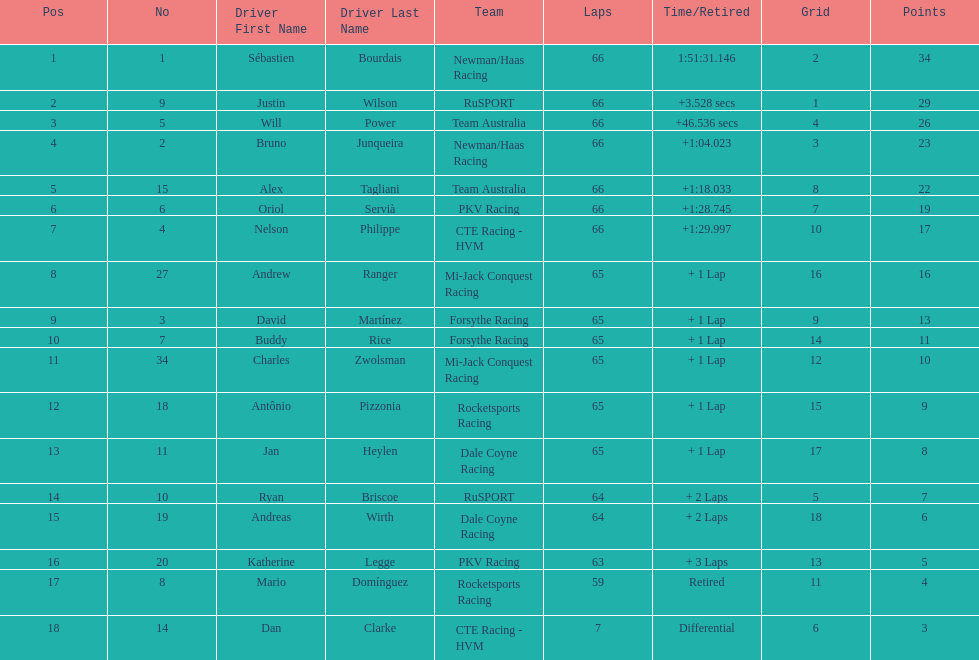At the 2006 gran premio telmex, who scored the highest number of points? Sébastien Bourdais. 